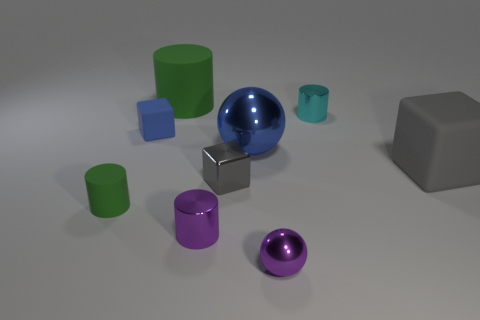How many cubes are small blue matte things or small red metal objects?
Ensure brevity in your answer.  1. There is a green matte cylinder that is behind the blue matte thing; is it the same size as the cube right of the small cyan object?
Offer a terse response. Yes. There is a gray block right of the ball that is behind the gray matte object; what is its material?
Provide a short and direct response. Rubber. Are there fewer small objects that are in front of the tiny gray object than green metal cylinders?
Offer a terse response. No. What shape is the gray thing that is made of the same material as the large sphere?
Ensure brevity in your answer.  Cube. How many other objects are there of the same shape as the large metal object?
Make the answer very short. 1. What number of green objects are either tiny objects or tiny rubber objects?
Keep it short and to the point. 1. Is the shape of the large gray thing the same as the blue rubber object?
Keep it short and to the point. Yes. Is there a green rubber cylinder that is in front of the gray cube to the left of the large gray object?
Keep it short and to the point. Yes. Are there an equal number of green things that are left of the small blue block and tiny green rubber objects?
Provide a succinct answer. Yes. 